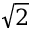<formula> <loc_0><loc_0><loc_500><loc_500>\sqrt { 2 }</formula> 